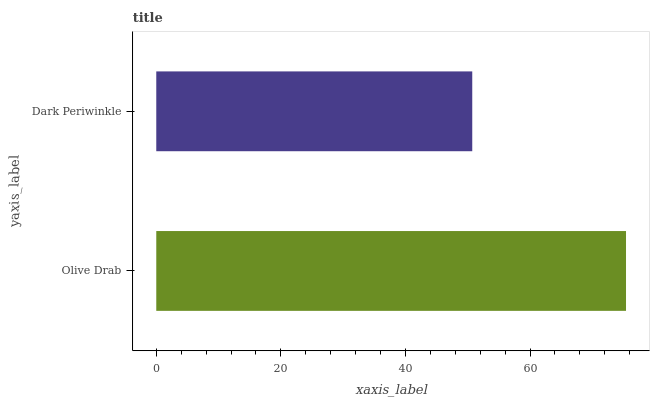Is Dark Periwinkle the minimum?
Answer yes or no. Yes. Is Olive Drab the maximum?
Answer yes or no. Yes. Is Dark Periwinkle the maximum?
Answer yes or no. No. Is Olive Drab greater than Dark Periwinkle?
Answer yes or no. Yes. Is Dark Periwinkle less than Olive Drab?
Answer yes or no. Yes. Is Dark Periwinkle greater than Olive Drab?
Answer yes or no. No. Is Olive Drab less than Dark Periwinkle?
Answer yes or no. No. Is Olive Drab the high median?
Answer yes or no. Yes. Is Dark Periwinkle the low median?
Answer yes or no. Yes. Is Dark Periwinkle the high median?
Answer yes or no. No. Is Olive Drab the low median?
Answer yes or no. No. 